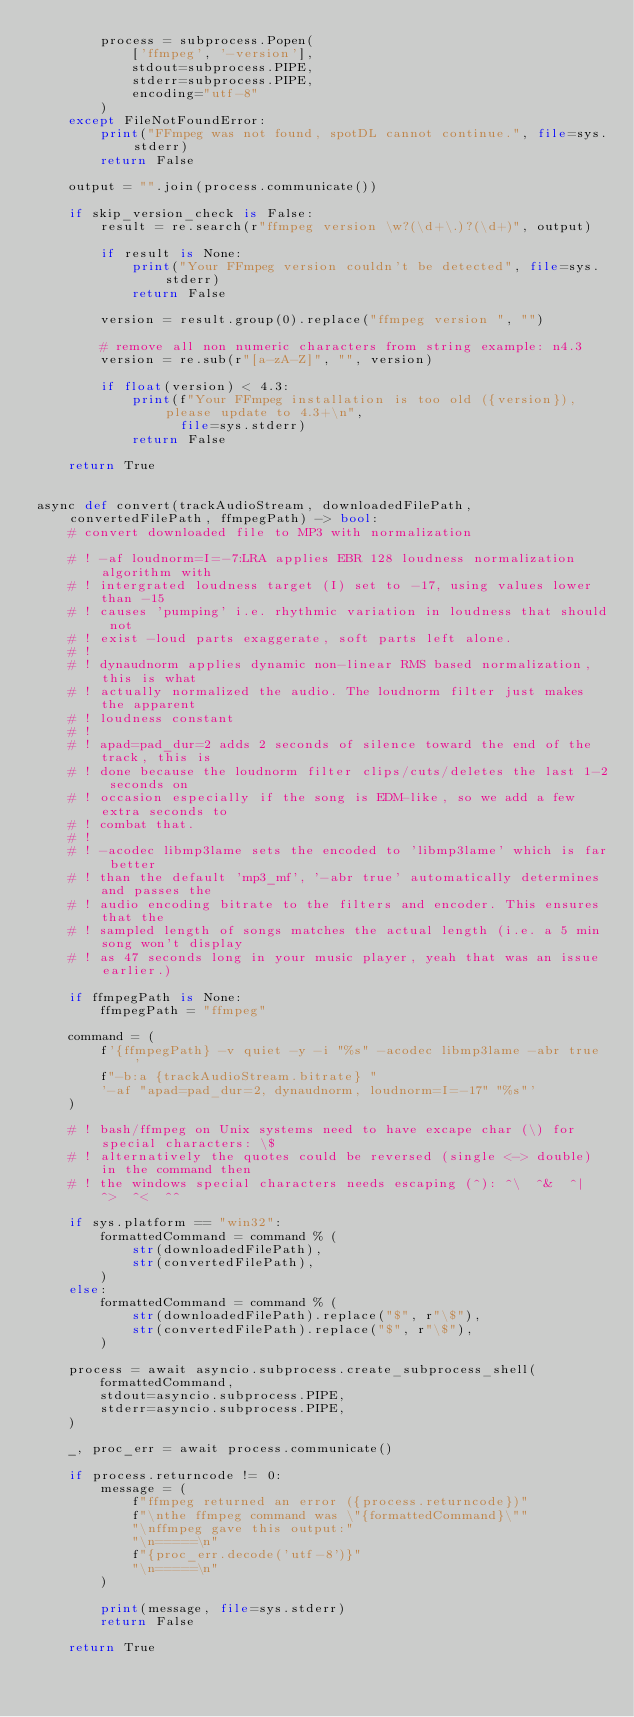<code> <loc_0><loc_0><loc_500><loc_500><_Python_>        process = subprocess.Popen(
            ['ffmpeg', '-version'],
            stdout=subprocess.PIPE,
            stderr=subprocess.PIPE,
            encoding="utf-8"
        )
    except FileNotFoundError:
        print("FFmpeg was not found, spotDL cannot continue.", file=sys.stderr)
        return False

    output = "".join(process.communicate())

    if skip_version_check is False:
        result = re.search(r"ffmpeg version \w?(\d+\.)?(\d+)", output)

        if result is None:
            print("Your FFmpeg version couldn't be detected", file=sys.stderr)
            return False

        version = result.group(0).replace("ffmpeg version ", "")

        # remove all non numeric characters from string example: n4.3
        version = re.sub(r"[a-zA-Z]", "", version)

        if float(version) < 4.3:
            print(f"Your FFmpeg installation is too old ({version}), please update to 4.3+\n",
                  file=sys.stderr)
            return False

    return True


async def convert(trackAudioStream, downloadedFilePath, convertedFilePath, ffmpegPath) -> bool:
    # convert downloaded file to MP3 with normalization

    # ! -af loudnorm=I=-7:LRA applies EBR 128 loudness normalization algorithm with
    # ! intergrated loudness target (I) set to -17, using values lower than -15
    # ! causes 'pumping' i.e. rhythmic variation in loudness that should not
    # ! exist -loud parts exaggerate, soft parts left alone.
    # !
    # ! dynaudnorm applies dynamic non-linear RMS based normalization, this is what
    # ! actually normalized the audio. The loudnorm filter just makes the apparent
    # ! loudness constant
    # !
    # ! apad=pad_dur=2 adds 2 seconds of silence toward the end of the track, this is
    # ! done because the loudnorm filter clips/cuts/deletes the last 1-2 seconds on
    # ! occasion especially if the song is EDM-like, so we add a few extra seconds to
    # ! combat that.
    # !
    # ! -acodec libmp3lame sets the encoded to 'libmp3lame' which is far better
    # ! than the default 'mp3_mf', '-abr true' automatically determines and passes the
    # ! audio encoding bitrate to the filters and encoder. This ensures that the
    # ! sampled length of songs matches the actual length (i.e. a 5 min song won't display
    # ! as 47 seconds long in your music player, yeah that was an issue earlier.)

    if ffmpegPath is None:
        ffmpegPath = "ffmpeg"

    command = (
        f'{ffmpegPath} -v quiet -y -i "%s" -acodec libmp3lame -abr true '
        f"-b:a {trackAudioStream.bitrate} "
        '-af "apad=pad_dur=2, dynaudnorm, loudnorm=I=-17" "%s"'
    )

    # ! bash/ffmpeg on Unix systems need to have excape char (\) for special characters: \$
    # ! alternatively the quotes could be reversed (single <-> double) in the command then
    # ! the windows special characters needs escaping (^): ^\  ^&  ^|  ^>  ^<  ^^

    if sys.platform == "win32":
        formattedCommand = command % (
            str(downloadedFilePath),
            str(convertedFilePath),
        )
    else:
        formattedCommand = command % (
            str(downloadedFilePath).replace("$", r"\$"),
            str(convertedFilePath).replace("$", r"\$"),
        )

    process = await asyncio.subprocess.create_subprocess_shell(
        formattedCommand,
        stdout=asyncio.subprocess.PIPE,
        stderr=asyncio.subprocess.PIPE,
    )

    _, proc_err = await process.communicate()

    if process.returncode != 0:
        message = (
            f"ffmpeg returned an error ({process.returncode})"
            f"\nthe ffmpeg command was \"{formattedCommand}\""
            "\nffmpeg gave this output:"
            "\n=====\n"
            f"{proc_err.decode('utf-8')}"
            "\n=====\n"
        )

        print(message, file=sys.stderr)
        return False

    return True
</code> 